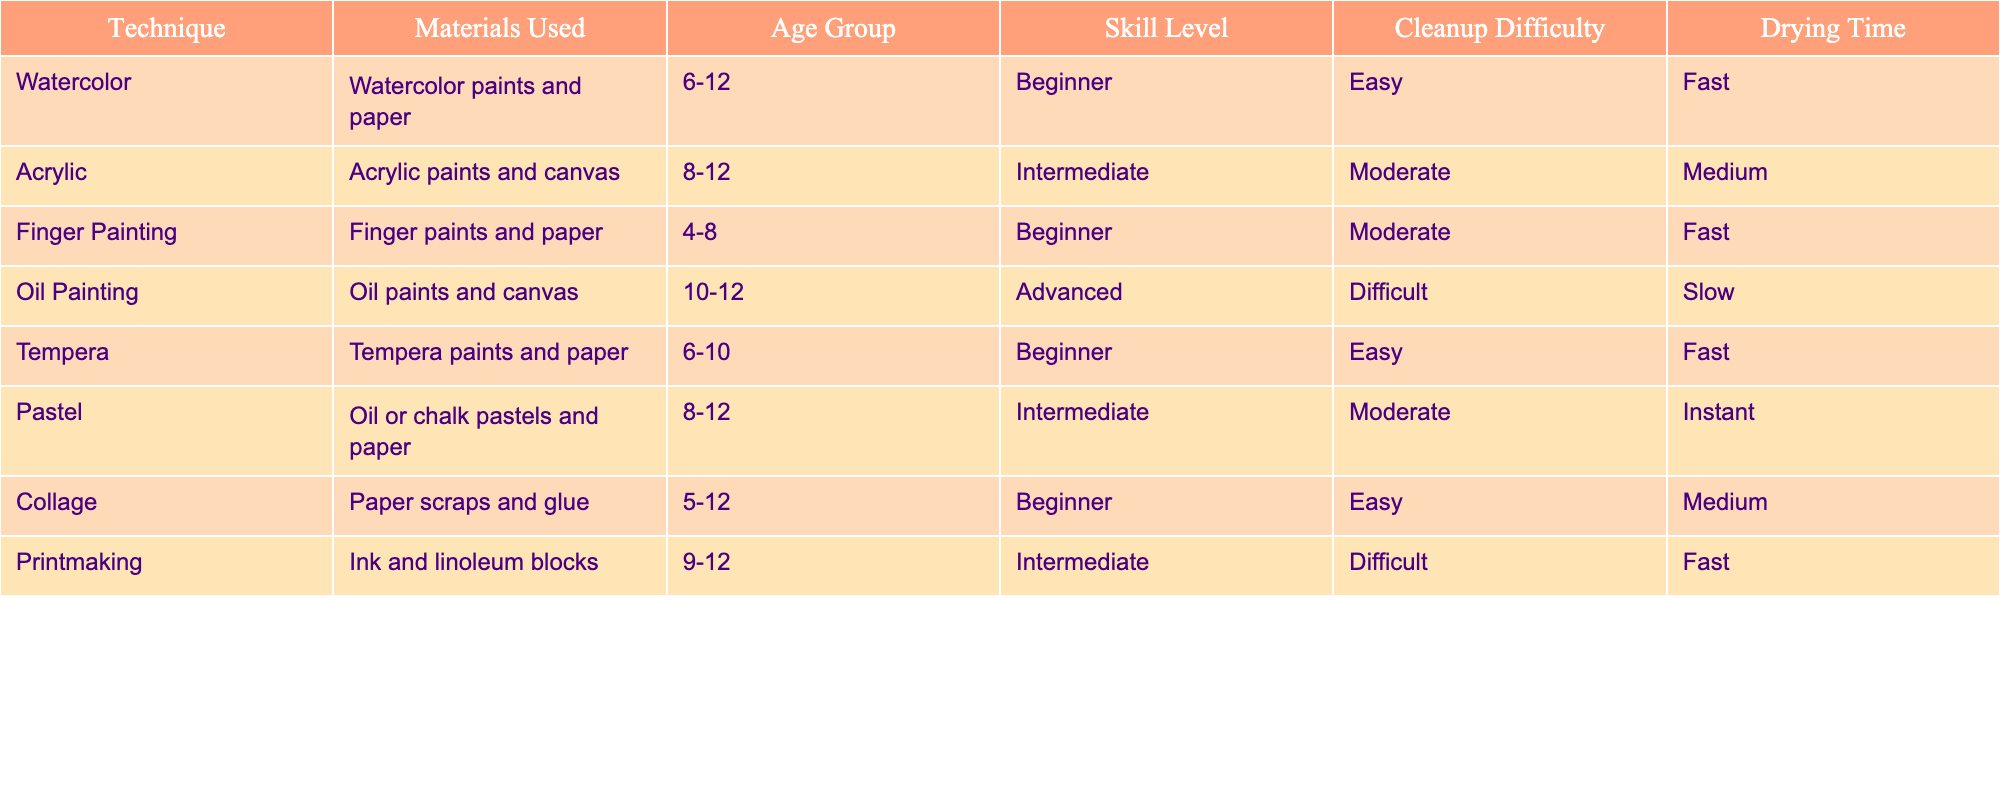What is the skill level required for watercolor painting? The table indicates that watercolor painting has a skill level categorized as 'Beginner'. This was located in the 'Skill Level' column next to the 'Watercolor' technique in the table.
Answer: Beginner Which painting technique uses oil paints? The table shows that oil painting is the technique that utilizes oil paints and canvas. This can be found in the corresponding row under the 'Technique' and 'Materials Used' columns.
Answer: Oil painting How many painting techniques are suitable for the age group of 10-12? By examining the table, there are two techniques listed for the age group of 10-12: Oil Painting and Acrylic. This was determined by filtering the 'Age Group' column to find entries that match 10-12.
Answer: 2 Are there any techniques with easy cleanup difficulty that are suitable for children aged 6-12? Yes, the techniques that have an 'Easy' cleanup difficulty and fall within the age group of 6-12 are Watercolor and Tempera. These were identified by checking the 'Cleanup Difficulty' and 'Age Group' columns.
Answer: Yes What is the average drying time for techniques that are considered Intermediate? The Intermediate techniques are Acrylic, Pastel, and Printmaking, with drying times of Medium, Instant, and Fast respectively. To calculate the average, I convert these to numerical values: Medium (2), Instant (1), and Fast (1) which leads to a sum of 4 and then divide by 3 (the number of techniques), resulting in an average drying time value of approximately 1.33 which can be categorized back.
Answer: Fast How many techniques listed use paper as a primary material? From reviewing the table, the following techniques use paper: Watercolor, Finger Painting, Tempera, Collage, and Pastel. By counting all the instances identified in the 'Materials Used' column, I found there are five.
Answer: 5 Is there a painting technique suitable for aged 4-8 with moderate cleanup difficulty? No, upon examining the table, the only technique suitable for the age group of 4-8 is Finger Painting, which has a moderate cleanup difficulty. However, it does not fit the criteria of being both suitable for that age and having moderate cleanup since it falls under 'Moderate' but does have a moderate difficulty.
Answer: No What is the total number of beginners' techniques available? The techniques classified as beginners are Watercolor, Finger Painting, Tempera, and Collage. To find the total, I simply count these entries listed under the 'Skill Level' column that are marked as 'Beginner'. This results in four techniques in total.
Answer: 4 How does the cleanup difficulty of acrylic compare to oil painting? The table shows that acrylic has a 'Moderate' cleanup difficulty, while oil painting has a 'Difficult' cleanup difficulty. This comparison indicates that acrylic is easier to clean up than oil painting. Thus, acrylic requires less effort in this regard.
Answer: Easier 